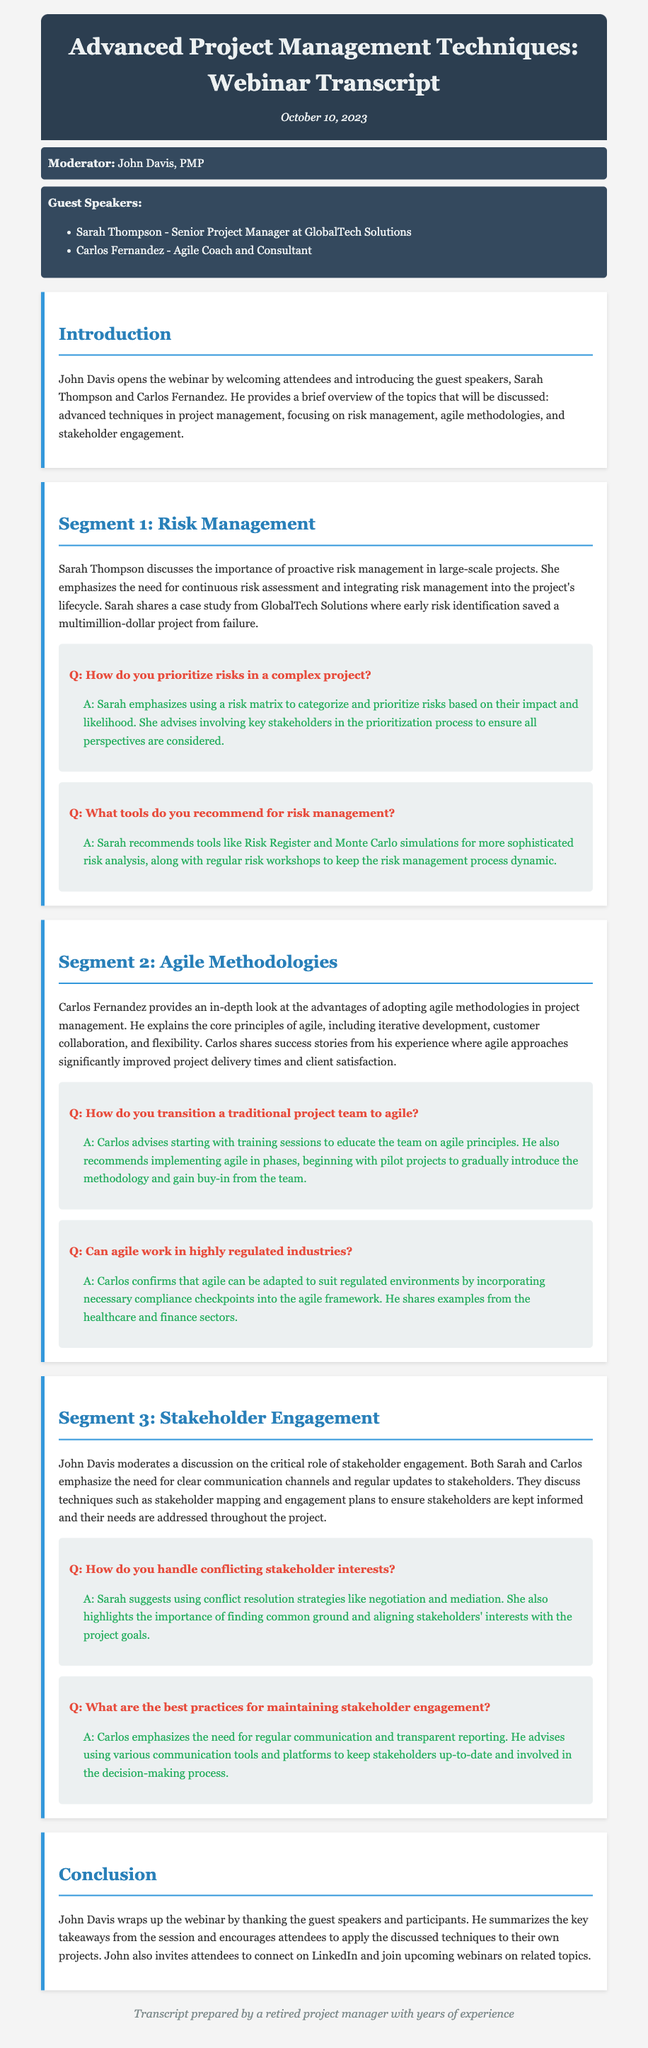What is the date of the webinar? The date of the webinar is specified in the header of the document, which is October 10, 2023.
Answer: October 10, 2023 Who is the moderator of the webinar? The moderator is named in the document, specifically in the "moderator" section, which lists John Davis, PMP.
Answer: John Davis, PMP What company does Sarah Thompson represent? Sarah Thompson's affiliation is mentioned in the "guests" section, identifying her as a Senior Project Manager at GlobalTech Solutions.
Answer: GlobalTech Solutions What tools does Sarah recommend for risk management? The response includes specific tools mentioned by Sarah in the risk management segment, which are Risk Register and Monte Carlo simulations.
Answer: Risk Register and Monte Carlo simulations How do Carlos and Sarah suggest handling conflicting stakeholder interests? The suggested strategies for handling conflicting stakeholder interests are detailed in the engagement segment, mentioning negotiation and mediation.
Answer: Negotiation and mediation Which agile principles does Carlos highlight? Carlos discusses the core principles in the agile methodologies segment, including iterative development, customer collaboration, and flexibility.
Answer: Iterative development, customer collaboration, and flexibility What is a key takeaway from the conclusion? The conclusion summarizes that attendees are encouraged to apply the discussed techniques to their own projects, which is stated explicitly.
Answer: Apply the discussed techniques to their own projects How does Carlos propose transitioning a traditional project team to agile? The response about transitioning a project team to agile includes starting with training sessions, as mentioned in the agile methodologies segment.
Answer: Training sessions What should be included in a stakeholder engagement plan? Techniques such as stakeholder mapping and engagement plans are mentioned as essential components for stakeholder engagement, detailed in their segment.
Answer: Stakeholder mapping and engagement plans 